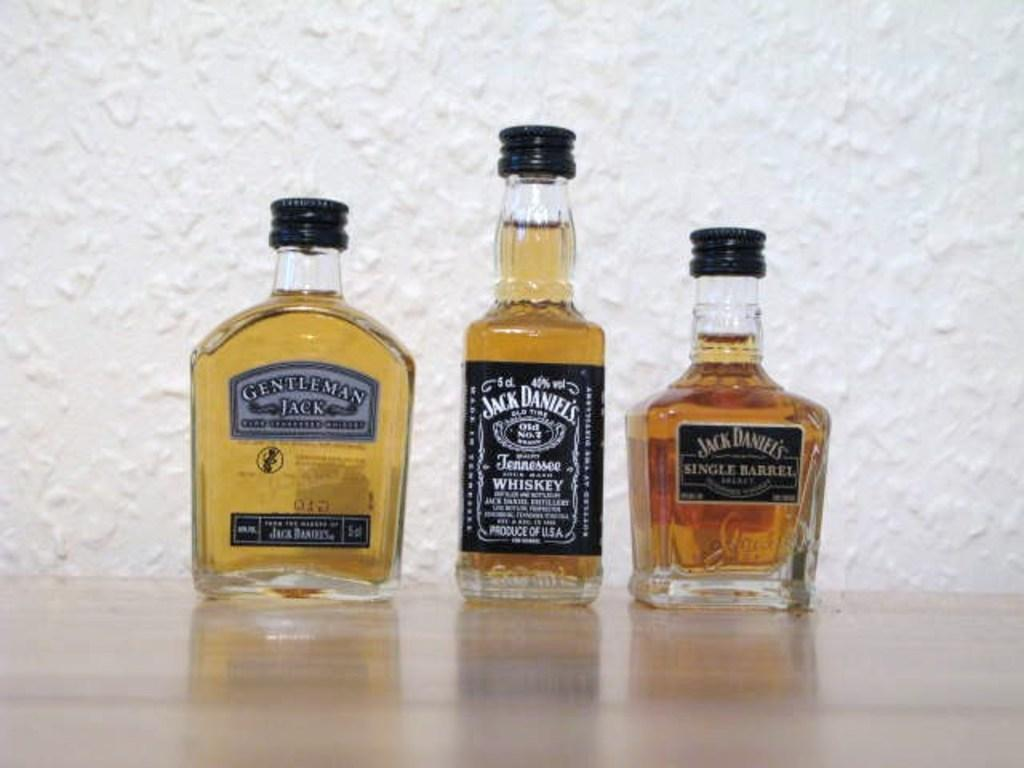<image>
Present a compact description of the photo's key features. Three bottles of whiskey with the middle one being Jack Daniels 